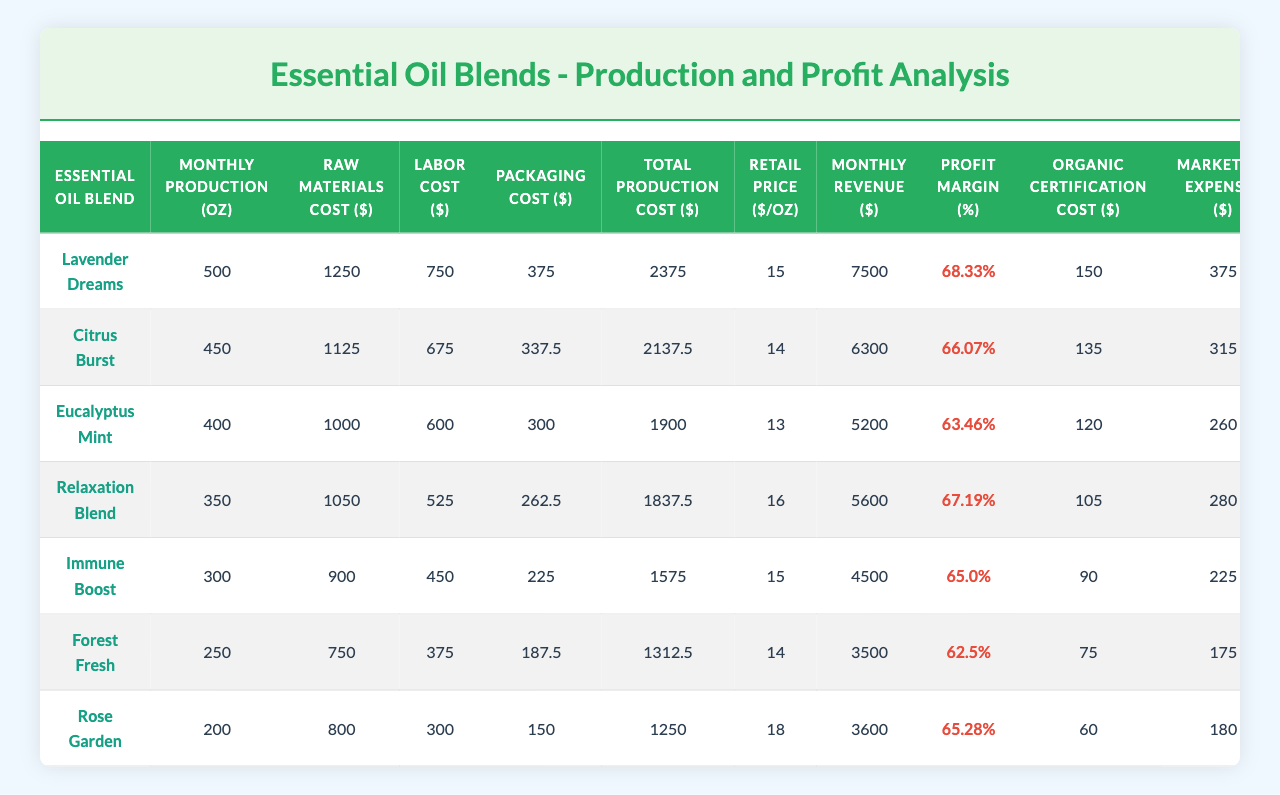What is the total production cost for the "Citrus Burst" blend? The total production cost of the "Citrus Burst" blend is listed in the table under the respective column, which shows $2137.50.
Answer: $2137.50 Which essential oil blend has the highest profit margin? By reviewing the profit margin percentages in the table, the "Lavender Dreams" blend has the highest margin at 68.33%.
Answer: "Lavender Dreams" What is the difference in monthly production between "Forest Fresh" and "Immune Boost"? "Forest Fresh" has a monthly production of 250 oz and "Immune Boost" has 300 oz. The difference is 300 oz - 250 oz = 50 oz.
Answer: 50 oz Is the organic certification cost for "Rose Garden" more than $75? The organic certification cost for "Rose Garden" is $60, which is less than $75, making it false that it is more than $75.
Answer: No Calculate the average retail price across all blends. The retail prices are 15, 14, 13, 16, 15, 14, and 18. The sum is 15 + 14 + 13 + 16 + 15 + 14 + 18 = 105, and there are 7 blends, so the average is 105/7 = 15.
Answer: $15 What is the total raw materials cost for all blends combined? By summing all raw materials costs: 1250 + 1125 + 1000 + 1050 + 900 + 750 + 800, the total comes to $5875.
Answer: $5875 Which blend has the lowest labor cost, and what is that cost? By checking the labor cost column, "Rose Garden" has the lowest labor cost listed at $300.
Answer: "Rose Garden", $300 If the "Relaxation Blend" increases its retail price to $18, what would its new profit margin be? Currently, the "Relaxation Blend" has a total cost of $1837.50 and a monthly revenue based on current pricing of $5600. New revenue would be 350 oz * $18 = $6300, profit = $6300 - $1837.50 = $4462.50, so the new margin would be ($4462.50 / $6300) * 100 = 70.86%.
Answer: 70.86% Which blend has a higher total production cost, "Immune Boost" or "Relaxation Blend"? "Immune Boost" has a total production cost of $1575, while "Relaxation Blend" has $1837.50. Since $1837.50 > $1575, "Relaxation Blend" has a higher cost.
Answer: "Relaxation Blend" Is the marketing expense for "Eucalyptus Mint" greater than the organic certification cost? The marketing expense for "Eucalyptus Mint" is $260, which is greater than the organic certification cost of $120. Hence, the statement is true.
Answer: Yes 